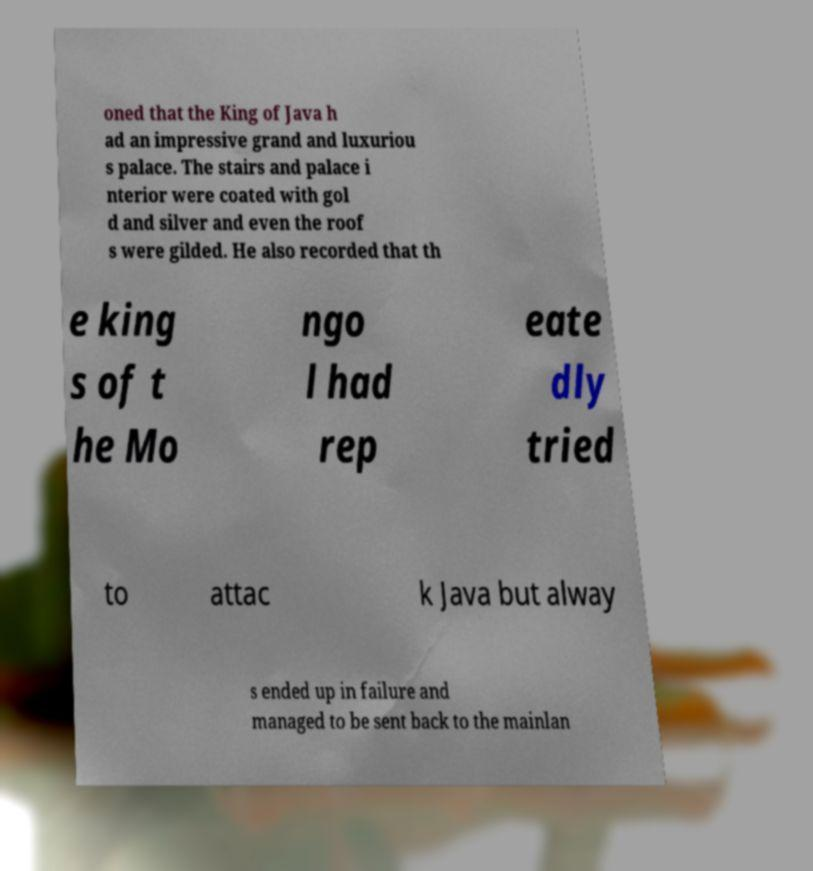Could you assist in decoding the text presented in this image and type it out clearly? oned that the King of Java h ad an impressive grand and luxuriou s palace. The stairs and palace i nterior were coated with gol d and silver and even the roof s were gilded. He also recorded that th e king s of t he Mo ngo l had rep eate dly tried to attac k Java but alway s ended up in failure and managed to be sent back to the mainlan 